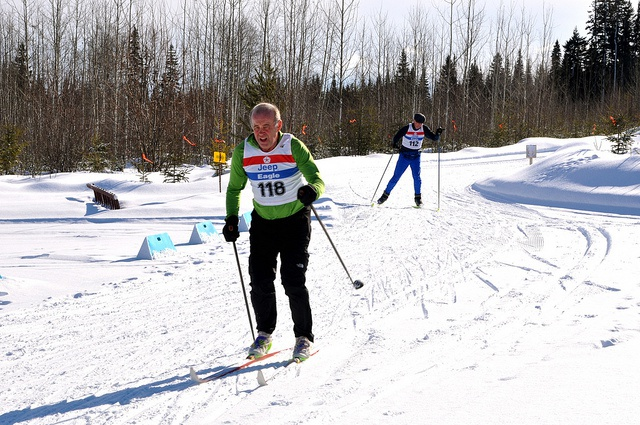Describe the objects in this image and their specific colors. I can see people in lightgray, black, darkgreen, and darkgray tones, people in lightgray, black, navy, darkblue, and darkgray tones, skis in lightgray, white, darkgray, gray, and salmon tones, and skis in lightgray, white, darkgray, olive, and green tones in this image. 